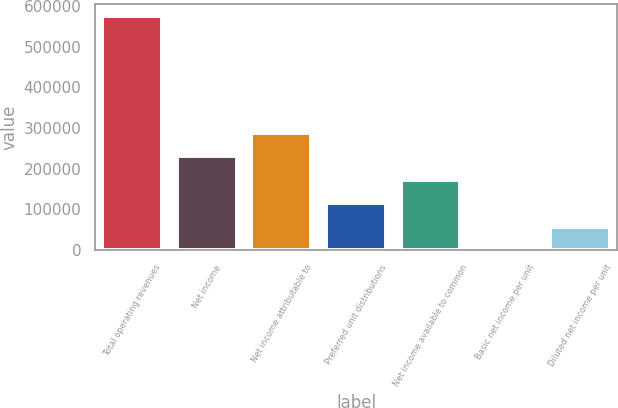Convert chart. <chart><loc_0><loc_0><loc_500><loc_500><bar_chart><fcel>Total operating revenues<fcel>Net income<fcel>Net income attributable to<fcel>Preferred unit distributions<fcel>Net income available to common<fcel>Basic net income per unit<fcel>Diluted net income per unit<nl><fcel>576787<fcel>230715<fcel>288394<fcel>115358<fcel>173036<fcel>0.49<fcel>57679.1<nl></chart> 